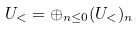Convert formula to latex. <formula><loc_0><loc_0><loc_500><loc_500>U _ { < } = \oplus _ { n \leq 0 } ( U _ { < } ) _ { n }</formula> 